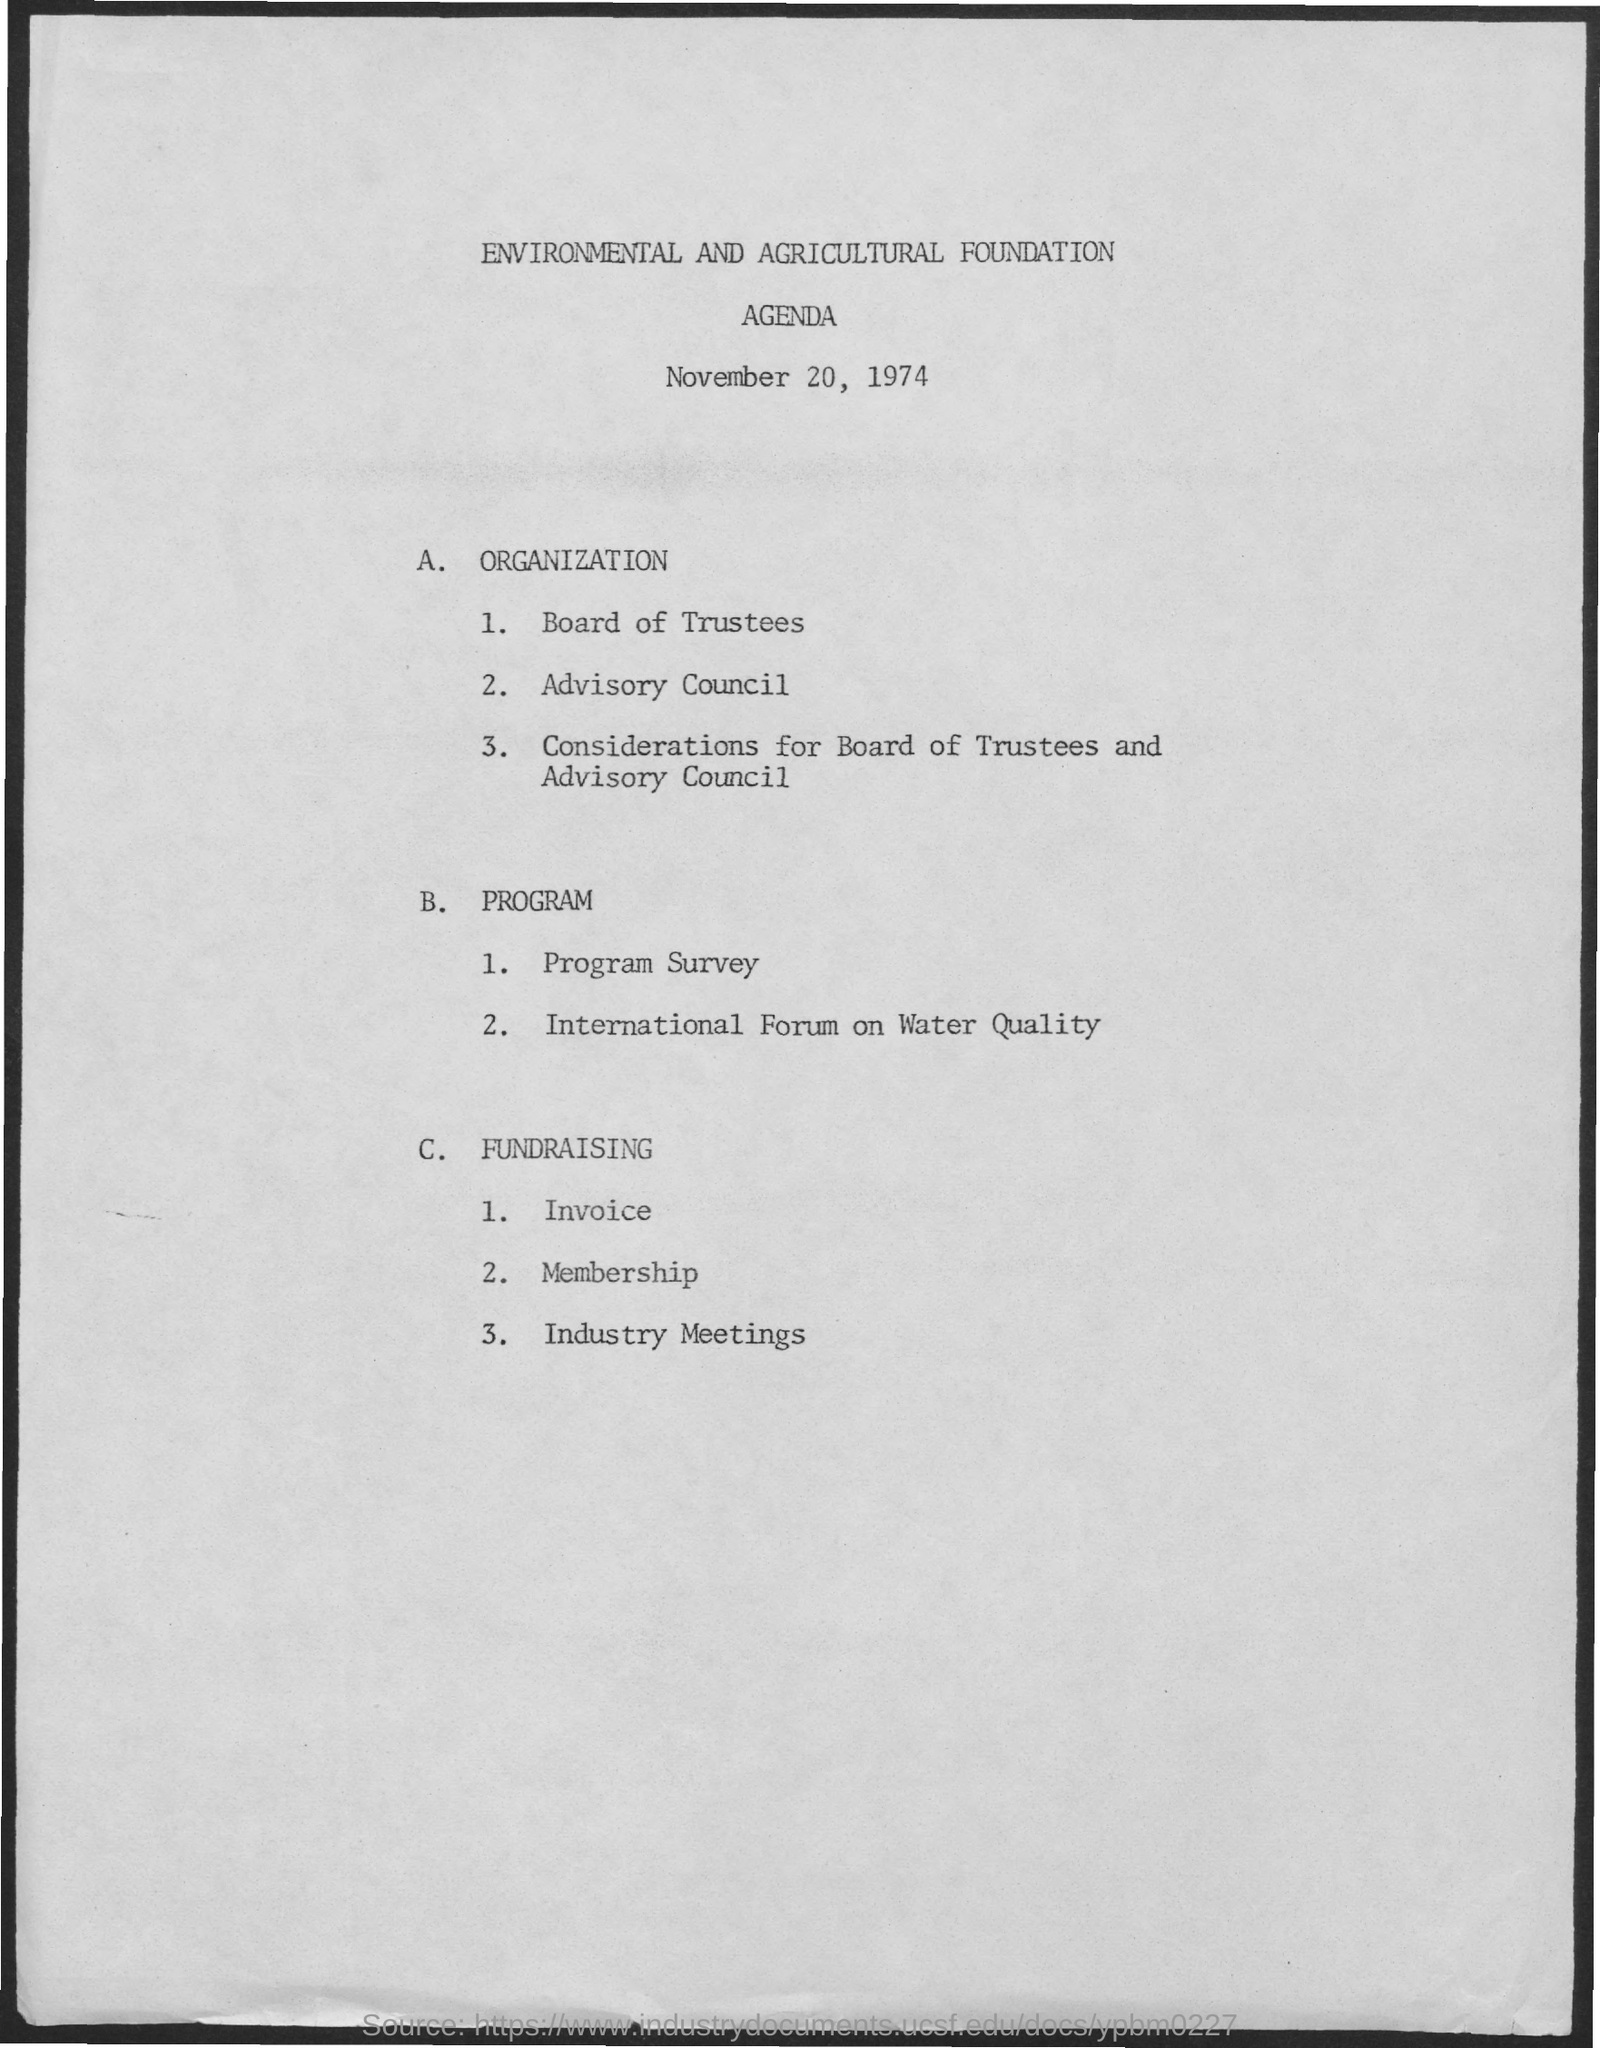Identify some key points in this picture. The title of the document is 'Environmental and Agricultural Foundation Agenda.' The date on the document is November 20, 1974. 